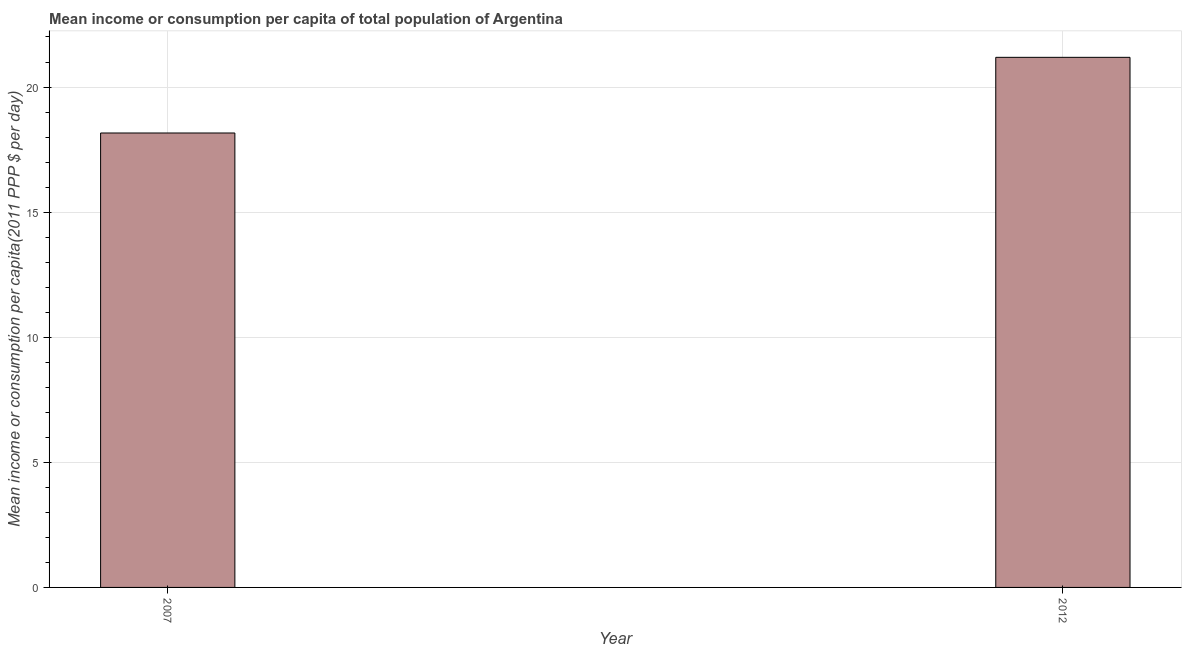What is the title of the graph?
Your response must be concise. Mean income or consumption per capita of total population of Argentina. What is the label or title of the X-axis?
Give a very brief answer. Year. What is the label or title of the Y-axis?
Your answer should be compact. Mean income or consumption per capita(2011 PPP $ per day). What is the mean income or consumption in 2012?
Keep it short and to the point. 21.19. Across all years, what is the maximum mean income or consumption?
Provide a succinct answer. 21.19. Across all years, what is the minimum mean income or consumption?
Keep it short and to the point. 18.16. In which year was the mean income or consumption maximum?
Give a very brief answer. 2012. What is the sum of the mean income or consumption?
Offer a very short reply. 39.35. What is the difference between the mean income or consumption in 2007 and 2012?
Provide a short and direct response. -3.02. What is the average mean income or consumption per year?
Ensure brevity in your answer.  19.68. What is the median mean income or consumption?
Make the answer very short. 19.68. What is the ratio of the mean income or consumption in 2007 to that in 2012?
Provide a succinct answer. 0.86. Are all the bars in the graph horizontal?
Make the answer very short. No. What is the Mean income or consumption per capita(2011 PPP $ per day) of 2007?
Your response must be concise. 18.16. What is the Mean income or consumption per capita(2011 PPP $ per day) in 2012?
Your response must be concise. 21.19. What is the difference between the Mean income or consumption per capita(2011 PPP $ per day) in 2007 and 2012?
Provide a succinct answer. -3.02. What is the ratio of the Mean income or consumption per capita(2011 PPP $ per day) in 2007 to that in 2012?
Offer a terse response. 0.86. 